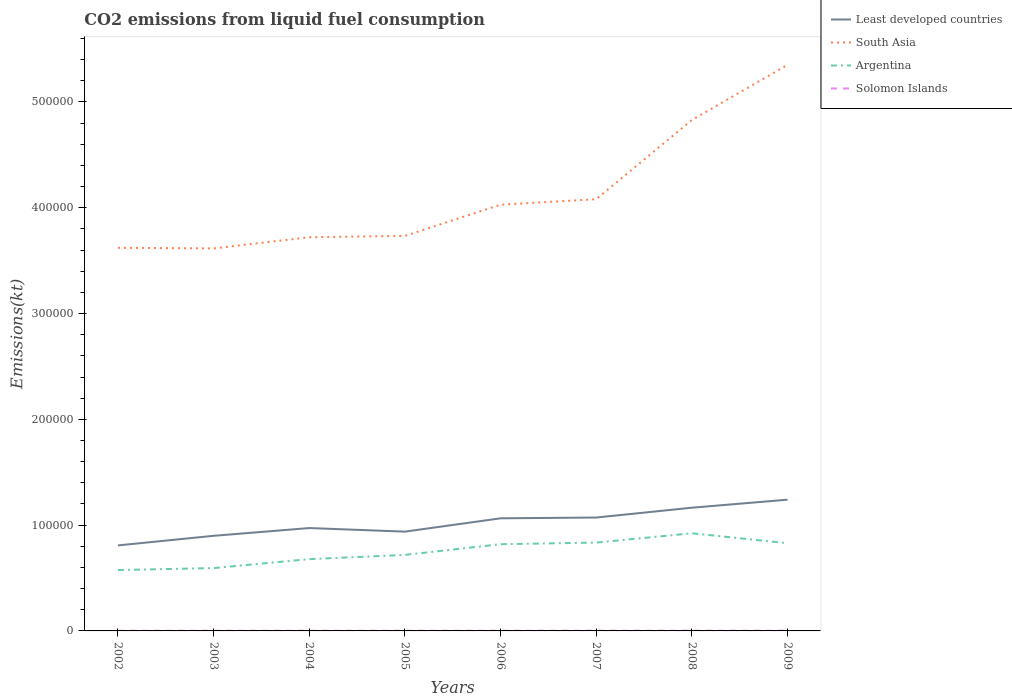How many different coloured lines are there?
Your answer should be very brief. 4. Across all years, what is the maximum amount of CO2 emitted in Argentina?
Your response must be concise. 5.75e+04. What is the total amount of CO2 emitted in Solomon Islands in the graph?
Offer a very short reply. 0. What is the difference between the highest and the second highest amount of CO2 emitted in Least developed countries?
Provide a short and direct response. 4.32e+04. What is the difference between the highest and the lowest amount of CO2 emitted in South Asia?
Your answer should be compact. 2. How many lines are there?
Offer a very short reply. 4. What is the difference between two consecutive major ticks on the Y-axis?
Provide a short and direct response. 1.00e+05. Are the values on the major ticks of Y-axis written in scientific E-notation?
Offer a very short reply. No. Does the graph contain grids?
Provide a succinct answer. No. How many legend labels are there?
Provide a succinct answer. 4. How are the legend labels stacked?
Your response must be concise. Vertical. What is the title of the graph?
Provide a short and direct response. CO2 emissions from liquid fuel consumption. What is the label or title of the X-axis?
Provide a succinct answer. Years. What is the label or title of the Y-axis?
Provide a short and direct response. Emissions(kt). What is the Emissions(kt) in Least developed countries in 2002?
Offer a terse response. 8.08e+04. What is the Emissions(kt) in South Asia in 2002?
Keep it short and to the point. 3.62e+05. What is the Emissions(kt) in Argentina in 2002?
Provide a succinct answer. 5.75e+04. What is the Emissions(kt) of Solomon Islands in 2002?
Offer a terse response. 172.35. What is the Emissions(kt) in Least developed countries in 2003?
Your response must be concise. 8.99e+04. What is the Emissions(kt) of South Asia in 2003?
Your answer should be very brief. 3.62e+05. What is the Emissions(kt) of Argentina in 2003?
Your answer should be very brief. 5.94e+04. What is the Emissions(kt) of Solomon Islands in 2003?
Offer a terse response. 179.68. What is the Emissions(kt) of Least developed countries in 2004?
Offer a terse response. 9.72e+04. What is the Emissions(kt) of South Asia in 2004?
Offer a very short reply. 3.72e+05. What is the Emissions(kt) in Argentina in 2004?
Make the answer very short. 6.79e+04. What is the Emissions(kt) in Solomon Islands in 2004?
Ensure brevity in your answer.  179.68. What is the Emissions(kt) in Least developed countries in 2005?
Make the answer very short. 9.39e+04. What is the Emissions(kt) of South Asia in 2005?
Make the answer very short. 3.73e+05. What is the Emissions(kt) in Argentina in 2005?
Your answer should be compact. 7.19e+04. What is the Emissions(kt) of Solomon Islands in 2005?
Offer a very short reply. 179.68. What is the Emissions(kt) in Least developed countries in 2006?
Your answer should be compact. 1.06e+05. What is the Emissions(kt) in South Asia in 2006?
Make the answer very short. 4.03e+05. What is the Emissions(kt) in Argentina in 2006?
Offer a terse response. 8.20e+04. What is the Emissions(kt) in Solomon Islands in 2006?
Your response must be concise. 179.68. What is the Emissions(kt) of Least developed countries in 2007?
Make the answer very short. 1.07e+05. What is the Emissions(kt) of South Asia in 2007?
Make the answer very short. 4.08e+05. What is the Emissions(kt) in Argentina in 2007?
Provide a succinct answer. 8.35e+04. What is the Emissions(kt) in Solomon Islands in 2007?
Keep it short and to the point. 190.68. What is the Emissions(kt) in Least developed countries in 2008?
Ensure brevity in your answer.  1.16e+05. What is the Emissions(kt) in South Asia in 2008?
Offer a terse response. 4.83e+05. What is the Emissions(kt) in Argentina in 2008?
Offer a terse response. 9.23e+04. What is the Emissions(kt) in Solomon Islands in 2008?
Ensure brevity in your answer.  190.68. What is the Emissions(kt) in Least developed countries in 2009?
Give a very brief answer. 1.24e+05. What is the Emissions(kt) in South Asia in 2009?
Provide a short and direct response. 5.35e+05. What is the Emissions(kt) of Argentina in 2009?
Provide a short and direct response. 8.29e+04. What is the Emissions(kt) in Solomon Islands in 2009?
Offer a terse response. 194.35. Across all years, what is the maximum Emissions(kt) in Least developed countries?
Offer a very short reply. 1.24e+05. Across all years, what is the maximum Emissions(kt) in South Asia?
Give a very brief answer. 5.35e+05. Across all years, what is the maximum Emissions(kt) in Argentina?
Offer a very short reply. 9.23e+04. Across all years, what is the maximum Emissions(kt) in Solomon Islands?
Offer a terse response. 194.35. Across all years, what is the minimum Emissions(kt) of Least developed countries?
Keep it short and to the point. 8.08e+04. Across all years, what is the minimum Emissions(kt) of South Asia?
Your answer should be compact. 3.62e+05. Across all years, what is the minimum Emissions(kt) of Argentina?
Your answer should be very brief. 5.75e+04. Across all years, what is the minimum Emissions(kt) of Solomon Islands?
Your response must be concise. 172.35. What is the total Emissions(kt) of Least developed countries in the graph?
Give a very brief answer. 8.16e+05. What is the total Emissions(kt) of South Asia in the graph?
Keep it short and to the point. 3.30e+06. What is the total Emissions(kt) of Argentina in the graph?
Your answer should be compact. 5.97e+05. What is the total Emissions(kt) of Solomon Islands in the graph?
Make the answer very short. 1466.8. What is the difference between the Emissions(kt) in Least developed countries in 2002 and that in 2003?
Keep it short and to the point. -9081.77. What is the difference between the Emissions(kt) in South Asia in 2002 and that in 2003?
Give a very brief answer. 579.39. What is the difference between the Emissions(kt) in Argentina in 2002 and that in 2003?
Make the answer very short. -1862.84. What is the difference between the Emissions(kt) in Solomon Islands in 2002 and that in 2003?
Offer a terse response. -7.33. What is the difference between the Emissions(kt) in Least developed countries in 2002 and that in 2004?
Ensure brevity in your answer.  -1.64e+04. What is the difference between the Emissions(kt) of South Asia in 2002 and that in 2004?
Offer a very short reply. -9999.91. What is the difference between the Emissions(kt) in Argentina in 2002 and that in 2004?
Ensure brevity in your answer.  -1.03e+04. What is the difference between the Emissions(kt) in Solomon Islands in 2002 and that in 2004?
Your answer should be very brief. -7.33. What is the difference between the Emissions(kt) of Least developed countries in 2002 and that in 2005?
Make the answer very short. -1.30e+04. What is the difference between the Emissions(kt) of South Asia in 2002 and that in 2005?
Provide a short and direct response. -1.13e+04. What is the difference between the Emissions(kt) of Argentina in 2002 and that in 2005?
Offer a terse response. -1.43e+04. What is the difference between the Emissions(kt) of Solomon Islands in 2002 and that in 2005?
Keep it short and to the point. -7.33. What is the difference between the Emissions(kt) of Least developed countries in 2002 and that in 2006?
Keep it short and to the point. -2.56e+04. What is the difference between the Emissions(kt) in South Asia in 2002 and that in 2006?
Provide a succinct answer. -4.08e+04. What is the difference between the Emissions(kt) of Argentina in 2002 and that in 2006?
Offer a very short reply. -2.44e+04. What is the difference between the Emissions(kt) in Solomon Islands in 2002 and that in 2006?
Provide a short and direct response. -7.33. What is the difference between the Emissions(kt) of Least developed countries in 2002 and that in 2007?
Provide a short and direct response. -2.64e+04. What is the difference between the Emissions(kt) in South Asia in 2002 and that in 2007?
Keep it short and to the point. -4.59e+04. What is the difference between the Emissions(kt) in Argentina in 2002 and that in 2007?
Your response must be concise. -2.60e+04. What is the difference between the Emissions(kt) in Solomon Islands in 2002 and that in 2007?
Provide a succinct answer. -18.34. What is the difference between the Emissions(kt) of Least developed countries in 2002 and that in 2008?
Make the answer very short. -3.57e+04. What is the difference between the Emissions(kt) of South Asia in 2002 and that in 2008?
Offer a very short reply. -1.21e+05. What is the difference between the Emissions(kt) in Argentina in 2002 and that in 2008?
Offer a very short reply. -3.48e+04. What is the difference between the Emissions(kt) in Solomon Islands in 2002 and that in 2008?
Give a very brief answer. -18.34. What is the difference between the Emissions(kt) of Least developed countries in 2002 and that in 2009?
Your response must be concise. -4.32e+04. What is the difference between the Emissions(kt) of South Asia in 2002 and that in 2009?
Your answer should be very brief. -1.73e+05. What is the difference between the Emissions(kt) in Argentina in 2002 and that in 2009?
Provide a short and direct response. -2.54e+04. What is the difference between the Emissions(kt) in Solomon Islands in 2002 and that in 2009?
Offer a terse response. -22. What is the difference between the Emissions(kt) of Least developed countries in 2003 and that in 2004?
Your response must be concise. -7332.58. What is the difference between the Emissions(kt) of South Asia in 2003 and that in 2004?
Your response must be concise. -1.06e+04. What is the difference between the Emissions(kt) of Argentina in 2003 and that in 2004?
Offer a very short reply. -8463.44. What is the difference between the Emissions(kt) in Least developed countries in 2003 and that in 2005?
Keep it short and to the point. -3952.29. What is the difference between the Emissions(kt) in South Asia in 2003 and that in 2005?
Offer a terse response. -1.19e+04. What is the difference between the Emissions(kt) of Argentina in 2003 and that in 2005?
Offer a terse response. -1.25e+04. What is the difference between the Emissions(kt) of Solomon Islands in 2003 and that in 2005?
Give a very brief answer. 0. What is the difference between the Emissions(kt) in Least developed countries in 2003 and that in 2006?
Give a very brief answer. -1.65e+04. What is the difference between the Emissions(kt) in South Asia in 2003 and that in 2006?
Your answer should be very brief. -4.14e+04. What is the difference between the Emissions(kt) in Argentina in 2003 and that in 2006?
Your answer should be very brief. -2.26e+04. What is the difference between the Emissions(kt) of Solomon Islands in 2003 and that in 2006?
Provide a succinct answer. 0. What is the difference between the Emissions(kt) of Least developed countries in 2003 and that in 2007?
Offer a terse response. -1.73e+04. What is the difference between the Emissions(kt) in South Asia in 2003 and that in 2007?
Keep it short and to the point. -4.65e+04. What is the difference between the Emissions(kt) in Argentina in 2003 and that in 2007?
Provide a short and direct response. -2.41e+04. What is the difference between the Emissions(kt) in Solomon Islands in 2003 and that in 2007?
Give a very brief answer. -11. What is the difference between the Emissions(kt) of Least developed countries in 2003 and that in 2008?
Keep it short and to the point. -2.66e+04. What is the difference between the Emissions(kt) of South Asia in 2003 and that in 2008?
Offer a very short reply. -1.21e+05. What is the difference between the Emissions(kt) of Argentina in 2003 and that in 2008?
Offer a very short reply. -3.29e+04. What is the difference between the Emissions(kt) in Solomon Islands in 2003 and that in 2008?
Make the answer very short. -11. What is the difference between the Emissions(kt) of Least developed countries in 2003 and that in 2009?
Provide a succinct answer. -3.41e+04. What is the difference between the Emissions(kt) of South Asia in 2003 and that in 2009?
Your response must be concise. -1.74e+05. What is the difference between the Emissions(kt) in Argentina in 2003 and that in 2009?
Offer a terse response. -2.35e+04. What is the difference between the Emissions(kt) in Solomon Islands in 2003 and that in 2009?
Offer a very short reply. -14.67. What is the difference between the Emissions(kt) of Least developed countries in 2004 and that in 2005?
Offer a terse response. 3380.29. What is the difference between the Emissions(kt) of South Asia in 2004 and that in 2005?
Offer a very short reply. -1283.45. What is the difference between the Emissions(kt) of Argentina in 2004 and that in 2005?
Ensure brevity in your answer.  -3989.7. What is the difference between the Emissions(kt) of Solomon Islands in 2004 and that in 2005?
Give a very brief answer. 0. What is the difference between the Emissions(kt) of Least developed countries in 2004 and that in 2006?
Your answer should be very brief. -9199.86. What is the difference between the Emissions(kt) of South Asia in 2004 and that in 2006?
Offer a terse response. -3.08e+04. What is the difference between the Emissions(kt) in Argentina in 2004 and that in 2006?
Offer a very short reply. -1.41e+04. What is the difference between the Emissions(kt) in Least developed countries in 2004 and that in 2007?
Make the answer very short. -9941.61. What is the difference between the Emissions(kt) of South Asia in 2004 and that in 2007?
Your answer should be compact. -3.59e+04. What is the difference between the Emissions(kt) in Argentina in 2004 and that in 2007?
Keep it short and to the point. -1.56e+04. What is the difference between the Emissions(kt) in Solomon Islands in 2004 and that in 2007?
Your answer should be very brief. -11. What is the difference between the Emissions(kt) of Least developed countries in 2004 and that in 2008?
Your answer should be very brief. -1.92e+04. What is the difference between the Emissions(kt) in South Asia in 2004 and that in 2008?
Offer a very short reply. -1.11e+05. What is the difference between the Emissions(kt) of Argentina in 2004 and that in 2008?
Ensure brevity in your answer.  -2.44e+04. What is the difference between the Emissions(kt) of Solomon Islands in 2004 and that in 2008?
Ensure brevity in your answer.  -11. What is the difference between the Emissions(kt) in Least developed countries in 2004 and that in 2009?
Keep it short and to the point. -2.68e+04. What is the difference between the Emissions(kt) in South Asia in 2004 and that in 2009?
Give a very brief answer. -1.63e+05. What is the difference between the Emissions(kt) in Argentina in 2004 and that in 2009?
Give a very brief answer. -1.51e+04. What is the difference between the Emissions(kt) in Solomon Islands in 2004 and that in 2009?
Your answer should be compact. -14.67. What is the difference between the Emissions(kt) in Least developed countries in 2005 and that in 2006?
Keep it short and to the point. -1.26e+04. What is the difference between the Emissions(kt) of South Asia in 2005 and that in 2006?
Ensure brevity in your answer.  -2.95e+04. What is the difference between the Emissions(kt) in Argentina in 2005 and that in 2006?
Your response must be concise. -1.01e+04. What is the difference between the Emissions(kt) in Least developed countries in 2005 and that in 2007?
Make the answer very short. -1.33e+04. What is the difference between the Emissions(kt) of South Asia in 2005 and that in 2007?
Provide a succinct answer. -3.46e+04. What is the difference between the Emissions(kt) of Argentina in 2005 and that in 2007?
Provide a succinct answer. -1.16e+04. What is the difference between the Emissions(kt) of Solomon Islands in 2005 and that in 2007?
Provide a succinct answer. -11. What is the difference between the Emissions(kt) in Least developed countries in 2005 and that in 2008?
Make the answer very short. -2.26e+04. What is the difference between the Emissions(kt) of South Asia in 2005 and that in 2008?
Offer a terse response. -1.10e+05. What is the difference between the Emissions(kt) in Argentina in 2005 and that in 2008?
Provide a short and direct response. -2.05e+04. What is the difference between the Emissions(kt) in Solomon Islands in 2005 and that in 2008?
Keep it short and to the point. -11. What is the difference between the Emissions(kt) in Least developed countries in 2005 and that in 2009?
Your response must be concise. -3.02e+04. What is the difference between the Emissions(kt) of South Asia in 2005 and that in 2009?
Offer a terse response. -1.62e+05. What is the difference between the Emissions(kt) of Argentina in 2005 and that in 2009?
Keep it short and to the point. -1.11e+04. What is the difference between the Emissions(kt) in Solomon Islands in 2005 and that in 2009?
Offer a very short reply. -14.67. What is the difference between the Emissions(kt) of Least developed countries in 2006 and that in 2007?
Make the answer very short. -741.75. What is the difference between the Emissions(kt) in South Asia in 2006 and that in 2007?
Ensure brevity in your answer.  -5148.47. What is the difference between the Emissions(kt) in Argentina in 2006 and that in 2007?
Offer a terse response. -1518.14. What is the difference between the Emissions(kt) of Solomon Islands in 2006 and that in 2007?
Provide a succinct answer. -11. What is the difference between the Emissions(kt) of Least developed countries in 2006 and that in 2008?
Provide a short and direct response. -1.00e+04. What is the difference between the Emissions(kt) in South Asia in 2006 and that in 2008?
Provide a succinct answer. -8.00e+04. What is the difference between the Emissions(kt) of Argentina in 2006 and that in 2008?
Offer a very short reply. -1.03e+04. What is the difference between the Emissions(kt) of Solomon Islands in 2006 and that in 2008?
Your answer should be very brief. -11. What is the difference between the Emissions(kt) of Least developed countries in 2006 and that in 2009?
Your answer should be compact. -1.76e+04. What is the difference between the Emissions(kt) in South Asia in 2006 and that in 2009?
Provide a short and direct response. -1.32e+05. What is the difference between the Emissions(kt) in Argentina in 2006 and that in 2009?
Your answer should be compact. -942.42. What is the difference between the Emissions(kt) in Solomon Islands in 2006 and that in 2009?
Offer a terse response. -14.67. What is the difference between the Emissions(kt) in Least developed countries in 2007 and that in 2008?
Make the answer very short. -9295.17. What is the difference between the Emissions(kt) in South Asia in 2007 and that in 2008?
Your response must be concise. -7.49e+04. What is the difference between the Emissions(kt) in Argentina in 2007 and that in 2008?
Your response must be concise. -8815.47. What is the difference between the Emissions(kt) in Solomon Islands in 2007 and that in 2008?
Offer a terse response. 0. What is the difference between the Emissions(kt) of Least developed countries in 2007 and that in 2009?
Provide a short and direct response. -1.69e+04. What is the difference between the Emissions(kt) in South Asia in 2007 and that in 2009?
Offer a very short reply. -1.27e+05. What is the difference between the Emissions(kt) in Argentina in 2007 and that in 2009?
Your response must be concise. 575.72. What is the difference between the Emissions(kt) of Solomon Islands in 2007 and that in 2009?
Your answer should be very brief. -3.67. What is the difference between the Emissions(kt) in Least developed countries in 2008 and that in 2009?
Make the answer very short. -7571.93. What is the difference between the Emissions(kt) in South Asia in 2008 and that in 2009?
Give a very brief answer. -5.21e+04. What is the difference between the Emissions(kt) of Argentina in 2008 and that in 2009?
Make the answer very short. 9391.19. What is the difference between the Emissions(kt) of Solomon Islands in 2008 and that in 2009?
Ensure brevity in your answer.  -3.67. What is the difference between the Emissions(kt) of Least developed countries in 2002 and the Emissions(kt) of South Asia in 2003?
Keep it short and to the point. -2.81e+05. What is the difference between the Emissions(kt) of Least developed countries in 2002 and the Emissions(kt) of Argentina in 2003?
Your answer should be very brief. 2.14e+04. What is the difference between the Emissions(kt) of Least developed countries in 2002 and the Emissions(kt) of Solomon Islands in 2003?
Offer a terse response. 8.06e+04. What is the difference between the Emissions(kt) in South Asia in 2002 and the Emissions(kt) in Argentina in 2003?
Offer a very short reply. 3.03e+05. What is the difference between the Emissions(kt) in South Asia in 2002 and the Emissions(kt) in Solomon Islands in 2003?
Offer a terse response. 3.62e+05. What is the difference between the Emissions(kt) in Argentina in 2002 and the Emissions(kt) in Solomon Islands in 2003?
Make the answer very short. 5.74e+04. What is the difference between the Emissions(kt) in Least developed countries in 2002 and the Emissions(kt) in South Asia in 2004?
Provide a short and direct response. -2.91e+05. What is the difference between the Emissions(kt) in Least developed countries in 2002 and the Emissions(kt) in Argentina in 2004?
Your answer should be very brief. 1.30e+04. What is the difference between the Emissions(kt) in Least developed countries in 2002 and the Emissions(kt) in Solomon Islands in 2004?
Offer a very short reply. 8.06e+04. What is the difference between the Emissions(kt) in South Asia in 2002 and the Emissions(kt) in Argentina in 2004?
Provide a succinct answer. 2.94e+05. What is the difference between the Emissions(kt) in South Asia in 2002 and the Emissions(kt) in Solomon Islands in 2004?
Give a very brief answer. 3.62e+05. What is the difference between the Emissions(kt) of Argentina in 2002 and the Emissions(kt) of Solomon Islands in 2004?
Keep it short and to the point. 5.74e+04. What is the difference between the Emissions(kt) of Least developed countries in 2002 and the Emissions(kt) of South Asia in 2005?
Give a very brief answer. -2.93e+05. What is the difference between the Emissions(kt) in Least developed countries in 2002 and the Emissions(kt) in Argentina in 2005?
Provide a short and direct response. 8969.63. What is the difference between the Emissions(kt) in Least developed countries in 2002 and the Emissions(kt) in Solomon Islands in 2005?
Keep it short and to the point. 8.06e+04. What is the difference between the Emissions(kt) in South Asia in 2002 and the Emissions(kt) in Argentina in 2005?
Offer a very short reply. 2.90e+05. What is the difference between the Emissions(kt) of South Asia in 2002 and the Emissions(kt) of Solomon Islands in 2005?
Ensure brevity in your answer.  3.62e+05. What is the difference between the Emissions(kt) of Argentina in 2002 and the Emissions(kt) of Solomon Islands in 2005?
Make the answer very short. 5.74e+04. What is the difference between the Emissions(kt) of Least developed countries in 2002 and the Emissions(kt) of South Asia in 2006?
Offer a very short reply. -3.22e+05. What is the difference between the Emissions(kt) in Least developed countries in 2002 and the Emissions(kt) in Argentina in 2006?
Keep it short and to the point. -1151.29. What is the difference between the Emissions(kt) of Least developed countries in 2002 and the Emissions(kt) of Solomon Islands in 2006?
Your answer should be very brief. 8.06e+04. What is the difference between the Emissions(kt) in South Asia in 2002 and the Emissions(kt) in Argentina in 2006?
Your answer should be compact. 2.80e+05. What is the difference between the Emissions(kt) in South Asia in 2002 and the Emissions(kt) in Solomon Islands in 2006?
Provide a succinct answer. 3.62e+05. What is the difference between the Emissions(kt) in Argentina in 2002 and the Emissions(kt) in Solomon Islands in 2006?
Your answer should be compact. 5.74e+04. What is the difference between the Emissions(kt) in Least developed countries in 2002 and the Emissions(kt) in South Asia in 2007?
Keep it short and to the point. -3.27e+05. What is the difference between the Emissions(kt) in Least developed countries in 2002 and the Emissions(kt) in Argentina in 2007?
Your answer should be very brief. -2669.43. What is the difference between the Emissions(kt) in Least developed countries in 2002 and the Emissions(kt) in Solomon Islands in 2007?
Offer a very short reply. 8.06e+04. What is the difference between the Emissions(kt) of South Asia in 2002 and the Emissions(kt) of Argentina in 2007?
Provide a short and direct response. 2.79e+05. What is the difference between the Emissions(kt) of South Asia in 2002 and the Emissions(kt) of Solomon Islands in 2007?
Offer a terse response. 3.62e+05. What is the difference between the Emissions(kt) in Argentina in 2002 and the Emissions(kt) in Solomon Islands in 2007?
Give a very brief answer. 5.74e+04. What is the difference between the Emissions(kt) in Least developed countries in 2002 and the Emissions(kt) in South Asia in 2008?
Provide a succinct answer. -4.02e+05. What is the difference between the Emissions(kt) of Least developed countries in 2002 and the Emissions(kt) of Argentina in 2008?
Provide a short and direct response. -1.15e+04. What is the difference between the Emissions(kt) of Least developed countries in 2002 and the Emissions(kt) of Solomon Islands in 2008?
Keep it short and to the point. 8.06e+04. What is the difference between the Emissions(kt) in South Asia in 2002 and the Emissions(kt) in Argentina in 2008?
Your answer should be compact. 2.70e+05. What is the difference between the Emissions(kt) in South Asia in 2002 and the Emissions(kt) in Solomon Islands in 2008?
Ensure brevity in your answer.  3.62e+05. What is the difference between the Emissions(kt) of Argentina in 2002 and the Emissions(kt) of Solomon Islands in 2008?
Make the answer very short. 5.74e+04. What is the difference between the Emissions(kt) in Least developed countries in 2002 and the Emissions(kt) in South Asia in 2009?
Give a very brief answer. -4.54e+05. What is the difference between the Emissions(kt) of Least developed countries in 2002 and the Emissions(kt) of Argentina in 2009?
Offer a very short reply. -2093.71. What is the difference between the Emissions(kt) of Least developed countries in 2002 and the Emissions(kt) of Solomon Islands in 2009?
Your answer should be compact. 8.06e+04. What is the difference between the Emissions(kt) of South Asia in 2002 and the Emissions(kt) of Argentina in 2009?
Keep it short and to the point. 2.79e+05. What is the difference between the Emissions(kt) in South Asia in 2002 and the Emissions(kt) in Solomon Islands in 2009?
Give a very brief answer. 3.62e+05. What is the difference between the Emissions(kt) in Argentina in 2002 and the Emissions(kt) in Solomon Islands in 2009?
Offer a terse response. 5.73e+04. What is the difference between the Emissions(kt) in Least developed countries in 2003 and the Emissions(kt) in South Asia in 2004?
Ensure brevity in your answer.  -2.82e+05. What is the difference between the Emissions(kt) of Least developed countries in 2003 and the Emissions(kt) of Argentina in 2004?
Your answer should be compact. 2.20e+04. What is the difference between the Emissions(kt) of Least developed countries in 2003 and the Emissions(kt) of Solomon Islands in 2004?
Your answer should be compact. 8.97e+04. What is the difference between the Emissions(kt) of South Asia in 2003 and the Emissions(kt) of Argentina in 2004?
Your response must be concise. 2.94e+05. What is the difference between the Emissions(kt) of South Asia in 2003 and the Emissions(kt) of Solomon Islands in 2004?
Offer a very short reply. 3.61e+05. What is the difference between the Emissions(kt) in Argentina in 2003 and the Emissions(kt) in Solomon Islands in 2004?
Ensure brevity in your answer.  5.92e+04. What is the difference between the Emissions(kt) in Least developed countries in 2003 and the Emissions(kt) in South Asia in 2005?
Give a very brief answer. -2.84e+05. What is the difference between the Emissions(kt) of Least developed countries in 2003 and the Emissions(kt) of Argentina in 2005?
Offer a very short reply. 1.81e+04. What is the difference between the Emissions(kt) of Least developed countries in 2003 and the Emissions(kt) of Solomon Islands in 2005?
Offer a terse response. 8.97e+04. What is the difference between the Emissions(kt) of South Asia in 2003 and the Emissions(kt) of Argentina in 2005?
Your answer should be very brief. 2.90e+05. What is the difference between the Emissions(kt) in South Asia in 2003 and the Emissions(kt) in Solomon Islands in 2005?
Make the answer very short. 3.61e+05. What is the difference between the Emissions(kt) in Argentina in 2003 and the Emissions(kt) in Solomon Islands in 2005?
Provide a short and direct response. 5.92e+04. What is the difference between the Emissions(kt) of Least developed countries in 2003 and the Emissions(kt) of South Asia in 2006?
Your response must be concise. -3.13e+05. What is the difference between the Emissions(kt) in Least developed countries in 2003 and the Emissions(kt) in Argentina in 2006?
Make the answer very short. 7930.49. What is the difference between the Emissions(kt) of Least developed countries in 2003 and the Emissions(kt) of Solomon Islands in 2006?
Your answer should be compact. 8.97e+04. What is the difference between the Emissions(kt) in South Asia in 2003 and the Emissions(kt) in Argentina in 2006?
Ensure brevity in your answer.  2.80e+05. What is the difference between the Emissions(kt) in South Asia in 2003 and the Emissions(kt) in Solomon Islands in 2006?
Your response must be concise. 3.61e+05. What is the difference between the Emissions(kt) of Argentina in 2003 and the Emissions(kt) of Solomon Islands in 2006?
Make the answer very short. 5.92e+04. What is the difference between the Emissions(kt) of Least developed countries in 2003 and the Emissions(kt) of South Asia in 2007?
Ensure brevity in your answer.  -3.18e+05. What is the difference between the Emissions(kt) in Least developed countries in 2003 and the Emissions(kt) in Argentina in 2007?
Provide a short and direct response. 6412.35. What is the difference between the Emissions(kt) of Least developed countries in 2003 and the Emissions(kt) of Solomon Islands in 2007?
Provide a succinct answer. 8.97e+04. What is the difference between the Emissions(kt) of South Asia in 2003 and the Emissions(kt) of Argentina in 2007?
Ensure brevity in your answer.  2.78e+05. What is the difference between the Emissions(kt) of South Asia in 2003 and the Emissions(kt) of Solomon Islands in 2007?
Your answer should be very brief. 3.61e+05. What is the difference between the Emissions(kt) in Argentina in 2003 and the Emissions(kt) in Solomon Islands in 2007?
Provide a short and direct response. 5.92e+04. What is the difference between the Emissions(kt) of Least developed countries in 2003 and the Emissions(kt) of South Asia in 2008?
Provide a short and direct response. -3.93e+05. What is the difference between the Emissions(kt) in Least developed countries in 2003 and the Emissions(kt) in Argentina in 2008?
Ensure brevity in your answer.  -2403.12. What is the difference between the Emissions(kt) of Least developed countries in 2003 and the Emissions(kt) of Solomon Islands in 2008?
Keep it short and to the point. 8.97e+04. What is the difference between the Emissions(kt) of South Asia in 2003 and the Emissions(kt) of Argentina in 2008?
Make the answer very short. 2.69e+05. What is the difference between the Emissions(kt) in South Asia in 2003 and the Emissions(kt) in Solomon Islands in 2008?
Offer a very short reply. 3.61e+05. What is the difference between the Emissions(kt) of Argentina in 2003 and the Emissions(kt) of Solomon Islands in 2008?
Provide a short and direct response. 5.92e+04. What is the difference between the Emissions(kt) in Least developed countries in 2003 and the Emissions(kt) in South Asia in 2009?
Keep it short and to the point. -4.45e+05. What is the difference between the Emissions(kt) in Least developed countries in 2003 and the Emissions(kt) in Argentina in 2009?
Provide a short and direct response. 6988.07. What is the difference between the Emissions(kt) of Least developed countries in 2003 and the Emissions(kt) of Solomon Islands in 2009?
Offer a very short reply. 8.97e+04. What is the difference between the Emissions(kt) in South Asia in 2003 and the Emissions(kt) in Argentina in 2009?
Your answer should be compact. 2.79e+05. What is the difference between the Emissions(kt) of South Asia in 2003 and the Emissions(kt) of Solomon Islands in 2009?
Your response must be concise. 3.61e+05. What is the difference between the Emissions(kt) of Argentina in 2003 and the Emissions(kt) of Solomon Islands in 2009?
Your answer should be compact. 5.92e+04. What is the difference between the Emissions(kt) of Least developed countries in 2004 and the Emissions(kt) of South Asia in 2005?
Provide a succinct answer. -2.76e+05. What is the difference between the Emissions(kt) of Least developed countries in 2004 and the Emissions(kt) of Argentina in 2005?
Provide a succinct answer. 2.54e+04. What is the difference between the Emissions(kt) in Least developed countries in 2004 and the Emissions(kt) in Solomon Islands in 2005?
Offer a terse response. 9.71e+04. What is the difference between the Emissions(kt) of South Asia in 2004 and the Emissions(kt) of Argentina in 2005?
Provide a short and direct response. 3.00e+05. What is the difference between the Emissions(kt) in South Asia in 2004 and the Emissions(kt) in Solomon Islands in 2005?
Offer a terse response. 3.72e+05. What is the difference between the Emissions(kt) in Argentina in 2004 and the Emissions(kt) in Solomon Islands in 2005?
Ensure brevity in your answer.  6.77e+04. What is the difference between the Emissions(kt) of Least developed countries in 2004 and the Emissions(kt) of South Asia in 2006?
Your answer should be compact. -3.06e+05. What is the difference between the Emissions(kt) of Least developed countries in 2004 and the Emissions(kt) of Argentina in 2006?
Your response must be concise. 1.53e+04. What is the difference between the Emissions(kt) of Least developed countries in 2004 and the Emissions(kt) of Solomon Islands in 2006?
Your answer should be very brief. 9.71e+04. What is the difference between the Emissions(kt) of South Asia in 2004 and the Emissions(kt) of Argentina in 2006?
Ensure brevity in your answer.  2.90e+05. What is the difference between the Emissions(kt) of South Asia in 2004 and the Emissions(kt) of Solomon Islands in 2006?
Make the answer very short. 3.72e+05. What is the difference between the Emissions(kt) of Argentina in 2004 and the Emissions(kt) of Solomon Islands in 2006?
Keep it short and to the point. 6.77e+04. What is the difference between the Emissions(kt) in Least developed countries in 2004 and the Emissions(kt) in South Asia in 2007?
Offer a very short reply. -3.11e+05. What is the difference between the Emissions(kt) in Least developed countries in 2004 and the Emissions(kt) in Argentina in 2007?
Your answer should be compact. 1.37e+04. What is the difference between the Emissions(kt) in Least developed countries in 2004 and the Emissions(kt) in Solomon Islands in 2007?
Offer a very short reply. 9.71e+04. What is the difference between the Emissions(kt) of South Asia in 2004 and the Emissions(kt) of Argentina in 2007?
Offer a terse response. 2.89e+05. What is the difference between the Emissions(kt) of South Asia in 2004 and the Emissions(kt) of Solomon Islands in 2007?
Your response must be concise. 3.72e+05. What is the difference between the Emissions(kt) in Argentina in 2004 and the Emissions(kt) in Solomon Islands in 2007?
Ensure brevity in your answer.  6.77e+04. What is the difference between the Emissions(kt) of Least developed countries in 2004 and the Emissions(kt) of South Asia in 2008?
Your response must be concise. -3.86e+05. What is the difference between the Emissions(kt) in Least developed countries in 2004 and the Emissions(kt) in Argentina in 2008?
Offer a very short reply. 4929.46. What is the difference between the Emissions(kt) of Least developed countries in 2004 and the Emissions(kt) of Solomon Islands in 2008?
Provide a short and direct response. 9.71e+04. What is the difference between the Emissions(kt) of South Asia in 2004 and the Emissions(kt) of Argentina in 2008?
Offer a very short reply. 2.80e+05. What is the difference between the Emissions(kt) in South Asia in 2004 and the Emissions(kt) in Solomon Islands in 2008?
Your answer should be very brief. 3.72e+05. What is the difference between the Emissions(kt) in Argentina in 2004 and the Emissions(kt) in Solomon Islands in 2008?
Offer a terse response. 6.77e+04. What is the difference between the Emissions(kt) in Least developed countries in 2004 and the Emissions(kt) in South Asia in 2009?
Make the answer very short. -4.38e+05. What is the difference between the Emissions(kt) in Least developed countries in 2004 and the Emissions(kt) in Argentina in 2009?
Keep it short and to the point. 1.43e+04. What is the difference between the Emissions(kt) in Least developed countries in 2004 and the Emissions(kt) in Solomon Islands in 2009?
Keep it short and to the point. 9.70e+04. What is the difference between the Emissions(kt) in South Asia in 2004 and the Emissions(kt) in Argentina in 2009?
Offer a very short reply. 2.89e+05. What is the difference between the Emissions(kt) in South Asia in 2004 and the Emissions(kt) in Solomon Islands in 2009?
Your answer should be compact. 3.72e+05. What is the difference between the Emissions(kt) in Argentina in 2004 and the Emissions(kt) in Solomon Islands in 2009?
Your answer should be very brief. 6.77e+04. What is the difference between the Emissions(kt) in Least developed countries in 2005 and the Emissions(kt) in South Asia in 2006?
Provide a succinct answer. -3.09e+05. What is the difference between the Emissions(kt) of Least developed countries in 2005 and the Emissions(kt) of Argentina in 2006?
Provide a succinct answer. 1.19e+04. What is the difference between the Emissions(kt) of Least developed countries in 2005 and the Emissions(kt) of Solomon Islands in 2006?
Provide a short and direct response. 9.37e+04. What is the difference between the Emissions(kt) of South Asia in 2005 and the Emissions(kt) of Argentina in 2006?
Provide a succinct answer. 2.91e+05. What is the difference between the Emissions(kt) of South Asia in 2005 and the Emissions(kt) of Solomon Islands in 2006?
Provide a succinct answer. 3.73e+05. What is the difference between the Emissions(kt) of Argentina in 2005 and the Emissions(kt) of Solomon Islands in 2006?
Your response must be concise. 7.17e+04. What is the difference between the Emissions(kt) of Least developed countries in 2005 and the Emissions(kt) of South Asia in 2007?
Provide a succinct answer. -3.14e+05. What is the difference between the Emissions(kt) in Least developed countries in 2005 and the Emissions(kt) in Argentina in 2007?
Keep it short and to the point. 1.04e+04. What is the difference between the Emissions(kt) of Least developed countries in 2005 and the Emissions(kt) of Solomon Islands in 2007?
Offer a very short reply. 9.37e+04. What is the difference between the Emissions(kt) in South Asia in 2005 and the Emissions(kt) in Argentina in 2007?
Your response must be concise. 2.90e+05. What is the difference between the Emissions(kt) of South Asia in 2005 and the Emissions(kt) of Solomon Islands in 2007?
Your response must be concise. 3.73e+05. What is the difference between the Emissions(kt) of Argentina in 2005 and the Emissions(kt) of Solomon Islands in 2007?
Offer a very short reply. 7.17e+04. What is the difference between the Emissions(kt) in Least developed countries in 2005 and the Emissions(kt) in South Asia in 2008?
Offer a very short reply. -3.89e+05. What is the difference between the Emissions(kt) in Least developed countries in 2005 and the Emissions(kt) in Argentina in 2008?
Your answer should be compact. 1549.17. What is the difference between the Emissions(kt) of Least developed countries in 2005 and the Emissions(kt) of Solomon Islands in 2008?
Provide a succinct answer. 9.37e+04. What is the difference between the Emissions(kt) in South Asia in 2005 and the Emissions(kt) in Argentina in 2008?
Ensure brevity in your answer.  2.81e+05. What is the difference between the Emissions(kt) of South Asia in 2005 and the Emissions(kt) of Solomon Islands in 2008?
Keep it short and to the point. 3.73e+05. What is the difference between the Emissions(kt) in Argentina in 2005 and the Emissions(kt) in Solomon Islands in 2008?
Your response must be concise. 7.17e+04. What is the difference between the Emissions(kt) in Least developed countries in 2005 and the Emissions(kt) in South Asia in 2009?
Your answer should be compact. -4.41e+05. What is the difference between the Emissions(kt) in Least developed countries in 2005 and the Emissions(kt) in Argentina in 2009?
Offer a terse response. 1.09e+04. What is the difference between the Emissions(kt) of Least developed countries in 2005 and the Emissions(kt) of Solomon Islands in 2009?
Keep it short and to the point. 9.37e+04. What is the difference between the Emissions(kt) of South Asia in 2005 and the Emissions(kt) of Argentina in 2009?
Ensure brevity in your answer.  2.91e+05. What is the difference between the Emissions(kt) in South Asia in 2005 and the Emissions(kt) in Solomon Islands in 2009?
Offer a terse response. 3.73e+05. What is the difference between the Emissions(kt) in Argentina in 2005 and the Emissions(kt) in Solomon Islands in 2009?
Offer a very short reply. 7.17e+04. What is the difference between the Emissions(kt) in Least developed countries in 2006 and the Emissions(kt) in South Asia in 2007?
Keep it short and to the point. -3.02e+05. What is the difference between the Emissions(kt) in Least developed countries in 2006 and the Emissions(kt) in Argentina in 2007?
Keep it short and to the point. 2.29e+04. What is the difference between the Emissions(kt) of Least developed countries in 2006 and the Emissions(kt) of Solomon Islands in 2007?
Keep it short and to the point. 1.06e+05. What is the difference between the Emissions(kt) of South Asia in 2006 and the Emissions(kt) of Argentina in 2007?
Make the answer very short. 3.19e+05. What is the difference between the Emissions(kt) of South Asia in 2006 and the Emissions(kt) of Solomon Islands in 2007?
Ensure brevity in your answer.  4.03e+05. What is the difference between the Emissions(kt) in Argentina in 2006 and the Emissions(kt) in Solomon Islands in 2007?
Your response must be concise. 8.18e+04. What is the difference between the Emissions(kt) in Least developed countries in 2006 and the Emissions(kt) in South Asia in 2008?
Your answer should be compact. -3.77e+05. What is the difference between the Emissions(kt) in Least developed countries in 2006 and the Emissions(kt) in Argentina in 2008?
Provide a short and direct response. 1.41e+04. What is the difference between the Emissions(kt) of Least developed countries in 2006 and the Emissions(kt) of Solomon Islands in 2008?
Ensure brevity in your answer.  1.06e+05. What is the difference between the Emissions(kt) of South Asia in 2006 and the Emissions(kt) of Argentina in 2008?
Your answer should be very brief. 3.11e+05. What is the difference between the Emissions(kt) of South Asia in 2006 and the Emissions(kt) of Solomon Islands in 2008?
Your answer should be very brief. 4.03e+05. What is the difference between the Emissions(kt) of Argentina in 2006 and the Emissions(kt) of Solomon Islands in 2008?
Your answer should be compact. 8.18e+04. What is the difference between the Emissions(kt) of Least developed countries in 2006 and the Emissions(kt) of South Asia in 2009?
Provide a short and direct response. -4.29e+05. What is the difference between the Emissions(kt) of Least developed countries in 2006 and the Emissions(kt) of Argentina in 2009?
Ensure brevity in your answer.  2.35e+04. What is the difference between the Emissions(kt) in Least developed countries in 2006 and the Emissions(kt) in Solomon Islands in 2009?
Offer a very short reply. 1.06e+05. What is the difference between the Emissions(kt) in South Asia in 2006 and the Emissions(kt) in Argentina in 2009?
Give a very brief answer. 3.20e+05. What is the difference between the Emissions(kt) in South Asia in 2006 and the Emissions(kt) in Solomon Islands in 2009?
Give a very brief answer. 4.03e+05. What is the difference between the Emissions(kt) of Argentina in 2006 and the Emissions(kt) of Solomon Islands in 2009?
Offer a very short reply. 8.18e+04. What is the difference between the Emissions(kt) of Least developed countries in 2007 and the Emissions(kt) of South Asia in 2008?
Your answer should be very brief. -3.76e+05. What is the difference between the Emissions(kt) in Least developed countries in 2007 and the Emissions(kt) in Argentina in 2008?
Provide a short and direct response. 1.49e+04. What is the difference between the Emissions(kt) of Least developed countries in 2007 and the Emissions(kt) of Solomon Islands in 2008?
Ensure brevity in your answer.  1.07e+05. What is the difference between the Emissions(kt) in South Asia in 2007 and the Emissions(kt) in Argentina in 2008?
Make the answer very short. 3.16e+05. What is the difference between the Emissions(kt) in South Asia in 2007 and the Emissions(kt) in Solomon Islands in 2008?
Make the answer very short. 4.08e+05. What is the difference between the Emissions(kt) of Argentina in 2007 and the Emissions(kt) of Solomon Islands in 2008?
Keep it short and to the point. 8.33e+04. What is the difference between the Emissions(kt) in Least developed countries in 2007 and the Emissions(kt) in South Asia in 2009?
Offer a very short reply. -4.28e+05. What is the difference between the Emissions(kt) in Least developed countries in 2007 and the Emissions(kt) in Argentina in 2009?
Your response must be concise. 2.43e+04. What is the difference between the Emissions(kt) of Least developed countries in 2007 and the Emissions(kt) of Solomon Islands in 2009?
Your response must be concise. 1.07e+05. What is the difference between the Emissions(kt) in South Asia in 2007 and the Emissions(kt) in Argentina in 2009?
Make the answer very short. 3.25e+05. What is the difference between the Emissions(kt) of South Asia in 2007 and the Emissions(kt) of Solomon Islands in 2009?
Make the answer very short. 4.08e+05. What is the difference between the Emissions(kt) of Argentina in 2007 and the Emissions(kt) of Solomon Islands in 2009?
Your answer should be compact. 8.33e+04. What is the difference between the Emissions(kt) of Least developed countries in 2008 and the Emissions(kt) of South Asia in 2009?
Keep it short and to the point. -4.19e+05. What is the difference between the Emissions(kt) of Least developed countries in 2008 and the Emissions(kt) of Argentina in 2009?
Your answer should be very brief. 3.36e+04. What is the difference between the Emissions(kt) of Least developed countries in 2008 and the Emissions(kt) of Solomon Islands in 2009?
Give a very brief answer. 1.16e+05. What is the difference between the Emissions(kt) of South Asia in 2008 and the Emissions(kt) of Argentina in 2009?
Ensure brevity in your answer.  4.00e+05. What is the difference between the Emissions(kt) in South Asia in 2008 and the Emissions(kt) in Solomon Islands in 2009?
Ensure brevity in your answer.  4.83e+05. What is the difference between the Emissions(kt) of Argentina in 2008 and the Emissions(kt) of Solomon Islands in 2009?
Keep it short and to the point. 9.21e+04. What is the average Emissions(kt) of Least developed countries per year?
Make the answer very short. 1.02e+05. What is the average Emissions(kt) of South Asia per year?
Make the answer very short. 4.12e+05. What is the average Emissions(kt) in Argentina per year?
Your answer should be compact. 7.47e+04. What is the average Emissions(kt) of Solomon Islands per year?
Give a very brief answer. 183.35. In the year 2002, what is the difference between the Emissions(kt) in Least developed countries and Emissions(kt) in South Asia?
Make the answer very short. -2.81e+05. In the year 2002, what is the difference between the Emissions(kt) of Least developed countries and Emissions(kt) of Argentina?
Your answer should be compact. 2.33e+04. In the year 2002, what is the difference between the Emissions(kt) in Least developed countries and Emissions(kt) in Solomon Islands?
Offer a very short reply. 8.07e+04. In the year 2002, what is the difference between the Emissions(kt) of South Asia and Emissions(kt) of Argentina?
Your answer should be very brief. 3.05e+05. In the year 2002, what is the difference between the Emissions(kt) of South Asia and Emissions(kt) of Solomon Islands?
Your response must be concise. 3.62e+05. In the year 2002, what is the difference between the Emissions(kt) in Argentina and Emissions(kt) in Solomon Islands?
Offer a terse response. 5.74e+04. In the year 2003, what is the difference between the Emissions(kt) of Least developed countries and Emissions(kt) of South Asia?
Keep it short and to the point. -2.72e+05. In the year 2003, what is the difference between the Emissions(kt) in Least developed countries and Emissions(kt) in Argentina?
Your response must be concise. 3.05e+04. In the year 2003, what is the difference between the Emissions(kt) of Least developed countries and Emissions(kt) of Solomon Islands?
Your answer should be very brief. 8.97e+04. In the year 2003, what is the difference between the Emissions(kt) in South Asia and Emissions(kt) in Argentina?
Offer a terse response. 3.02e+05. In the year 2003, what is the difference between the Emissions(kt) of South Asia and Emissions(kt) of Solomon Islands?
Provide a short and direct response. 3.61e+05. In the year 2003, what is the difference between the Emissions(kt) of Argentina and Emissions(kt) of Solomon Islands?
Your response must be concise. 5.92e+04. In the year 2004, what is the difference between the Emissions(kt) in Least developed countries and Emissions(kt) in South Asia?
Your answer should be very brief. -2.75e+05. In the year 2004, what is the difference between the Emissions(kt) in Least developed countries and Emissions(kt) in Argentina?
Your response must be concise. 2.94e+04. In the year 2004, what is the difference between the Emissions(kt) of Least developed countries and Emissions(kt) of Solomon Islands?
Offer a terse response. 9.71e+04. In the year 2004, what is the difference between the Emissions(kt) of South Asia and Emissions(kt) of Argentina?
Keep it short and to the point. 3.04e+05. In the year 2004, what is the difference between the Emissions(kt) of South Asia and Emissions(kt) of Solomon Islands?
Your answer should be compact. 3.72e+05. In the year 2004, what is the difference between the Emissions(kt) of Argentina and Emissions(kt) of Solomon Islands?
Make the answer very short. 6.77e+04. In the year 2005, what is the difference between the Emissions(kt) of Least developed countries and Emissions(kt) of South Asia?
Provide a succinct answer. -2.80e+05. In the year 2005, what is the difference between the Emissions(kt) of Least developed countries and Emissions(kt) of Argentina?
Ensure brevity in your answer.  2.20e+04. In the year 2005, what is the difference between the Emissions(kt) of Least developed countries and Emissions(kt) of Solomon Islands?
Give a very brief answer. 9.37e+04. In the year 2005, what is the difference between the Emissions(kt) of South Asia and Emissions(kt) of Argentina?
Give a very brief answer. 3.02e+05. In the year 2005, what is the difference between the Emissions(kt) of South Asia and Emissions(kt) of Solomon Islands?
Provide a succinct answer. 3.73e+05. In the year 2005, what is the difference between the Emissions(kt) in Argentina and Emissions(kt) in Solomon Islands?
Ensure brevity in your answer.  7.17e+04. In the year 2006, what is the difference between the Emissions(kt) of Least developed countries and Emissions(kt) of South Asia?
Your response must be concise. -2.96e+05. In the year 2006, what is the difference between the Emissions(kt) in Least developed countries and Emissions(kt) in Argentina?
Make the answer very short. 2.45e+04. In the year 2006, what is the difference between the Emissions(kt) of Least developed countries and Emissions(kt) of Solomon Islands?
Give a very brief answer. 1.06e+05. In the year 2006, what is the difference between the Emissions(kt) of South Asia and Emissions(kt) of Argentina?
Offer a very short reply. 3.21e+05. In the year 2006, what is the difference between the Emissions(kt) in South Asia and Emissions(kt) in Solomon Islands?
Your answer should be compact. 4.03e+05. In the year 2006, what is the difference between the Emissions(kt) in Argentina and Emissions(kt) in Solomon Islands?
Ensure brevity in your answer.  8.18e+04. In the year 2007, what is the difference between the Emissions(kt) of Least developed countries and Emissions(kt) of South Asia?
Your answer should be compact. -3.01e+05. In the year 2007, what is the difference between the Emissions(kt) in Least developed countries and Emissions(kt) in Argentina?
Keep it short and to the point. 2.37e+04. In the year 2007, what is the difference between the Emissions(kt) of Least developed countries and Emissions(kt) of Solomon Islands?
Ensure brevity in your answer.  1.07e+05. In the year 2007, what is the difference between the Emissions(kt) of South Asia and Emissions(kt) of Argentina?
Provide a short and direct response. 3.25e+05. In the year 2007, what is the difference between the Emissions(kt) in South Asia and Emissions(kt) in Solomon Islands?
Your answer should be compact. 4.08e+05. In the year 2007, what is the difference between the Emissions(kt) in Argentina and Emissions(kt) in Solomon Islands?
Provide a short and direct response. 8.33e+04. In the year 2008, what is the difference between the Emissions(kt) of Least developed countries and Emissions(kt) of South Asia?
Your response must be concise. -3.66e+05. In the year 2008, what is the difference between the Emissions(kt) in Least developed countries and Emissions(kt) in Argentina?
Your response must be concise. 2.42e+04. In the year 2008, what is the difference between the Emissions(kt) of Least developed countries and Emissions(kt) of Solomon Islands?
Your response must be concise. 1.16e+05. In the year 2008, what is the difference between the Emissions(kt) of South Asia and Emissions(kt) of Argentina?
Offer a terse response. 3.91e+05. In the year 2008, what is the difference between the Emissions(kt) of South Asia and Emissions(kt) of Solomon Islands?
Make the answer very short. 4.83e+05. In the year 2008, what is the difference between the Emissions(kt) in Argentina and Emissions(kt) in Solomon Islands?
Keep it short and to the point. 9.21e+04. In the year 2009, what is the difference between the Emissions(kt) in Least developed countries and Emissions(kt) in South Asia?
Your response must be concise. -4.11e+05. In the year 2009, what is the difference between the Emissions(kt) of Least developed countries and Emissions(kt) of Argentina?
Make the answer very short. 4.11e+04. In the year 2009, what is the difference between the Emissions(kt) in Least developed countries and Emissions(kt) in Solomon Islands?
Keep it short and to the point. 1.24e+05. In the year 2009, what is the difference between the Emissions(kt) of South Asia and Emissions(kt) of Argentina?
Your answer should be very brief. 4.52e+05. In the year 2009, what is the difference between the Emissions(kt) of South Asia and Emissions(kt) of Solomon Islands?
Offer a very short reply. 5.35e+05. In the year 2009, what is the difference between the Emissions(kt) of Argentina and Emissions(kt) of Solomon Islands?
Keep it short and to the point. 8.27e+04. What is the ratio of the Emissions(kt) of Least developed countries in 2002 to that in 2003?
Make the answer very short. 0.9. What is the ratio of the Emissions(kt) of South Asia in 2002 to that in 2003?
Provide a short and direct response. 1. What is the ratio of the Emissions(kt) of Argentina in 2002 to that in 2003?
Keep it short and to the point. 0.97. What is the ratio of the Emissions(kt) of Solomon Islands in 2002 to that in 2003?
Your answer should be compact. 0.96. What is the ratio of the Emissions(kt) of Least developed countries in 2002 to that in 2004?
Provide a succinct answer. 0.83. What is the ratio of the Emissions(kt) of South Asia in 2002 to that in 2004?
Provide a succinct answer. 0.97. What is the ratio of the Emissions(kt) of Argentina in 2002 to that in 2004?
Ensure brevity in your answer.  0.85. What is the ratio of the Emissions(kt) in Solomon Islands in 2002 to that in 2004?
Offer a very short reply. 0.96. What is the ratio of the Emissions(kt) of Least developed countries in 2002 to that in 2005?
Keep it short and to the point. 0.86. What is the ratio of the Emissions(kt) of South Asia in 2002 to that in 2005?
Keep it short and to the point. 0.97. What is the ratio of the Emissions(kt) in Argentina in 2002 to that in 2005?
Provide a short and direct response. 0.8. What is the ratio of the Emissions(kt) of Solomon Islands in 2002 to that in 2005?
Make the answer very short. 0.96. What is the ratio of the Emissions(kt) of Least developed countries in 2002 to that in 2006?
Give a very brief answer. 0.76. What is the ratio of the Emissions(kt) in South Asia in 2002 to that in 2006?
Your response must be concise. 0.9. What is the ratio of the Emissions(kt) in Argentina in 2002 to that in 2006?
Make the answer very short. 0.7. What is the ratio of the Emissions(kt) of Solomon Islands in 2002 to that in 2006?
Provide a short and direct response. 0.96. What is the ratio of the Emissions(kt) in Least developed countries in 2002 to that in 2007?
Give a very brief answer. 0.75. What is the ratio of the Emissions(kt) in South Asia in 2002 to that in 2007?
Provide a short and direct response. 0.89. What is the ratio of the Emissions(kt) in Argentina in 2002 to that in 2007?
Ensure brevity in your answer.  0.69. What is the ratio of the Emissions(kt) in Solomon Islands in 2002 to that in 2007?
Provide a short and direct response. 0.9. What is the ratio of the Emissions(kt) in Least developed countries in 2002 to that in 2008?
Provide a succinct answer. 0.69. What is the ratio of the Emissions(kt) of South Asia in 2002 to that in 2008?
Your answer should be very brief. 0.75. What is the ratio of the Emissions(kt) in Argentina in 2002 to that in 2008?
Offer a terse response. 0.62. What is the ratio of the Emissions(kt) in Solomon Islands in 2002 to that in 2008?
Provide a succinct answer. 0.9. What is the ratio of the Emissions(kt) of Least developed countries in 2002 to that in 2009?
Provide a succinct answer. 0.65. What is the ratio of the Emissions(kt) of South Asia in 2002 to that in 2009?
Make the answer very short. 0.68. What is the ratio of the Emissions(kt) in Argentina in 2002 to that in 2009?
Your answer should be compact. 0.69. What is the ratio of the Emissions(kt) in Solomon Islands in 2002 to that in 2009?
Make the answer very short. 0.89. What is the ratio of the Emissions(kt) of Least developed countries in 2003 to that in 2004?
Give a very brief answer. 0.92. What is the ratio of the Emissions(kt) of South Asia in 2003 to that in 2004?
Make the answer very short. 0.97. What is the ratio of the Emissions(kt) in Argentina in 2003 to that in 2004?
Make the answer very short. 0.88. What is the ratio of the Emissions(kt) of Solomon Islands in 2003 to that in 2004?
Keep it short and to the point. 1. What is the ratio of the Emissions(kt) of Least developed countries in 2003 to that in 2005?
Offer a terse response. 0.96. What is the ratio of the Emissions(kt) in South Asia in 2003 to that in 2005?
Keep it short and to the point. 0.97. What is the ratio of the Emissions(kt) in Argentina in 2003 to that in 2005?
Provide a succinct answer. 0.83. What is the ratio of the Emissions(kt) of Solomon Islands in 2003 to that in 2005?
Keep it short and to the point. 1. What is the ratio of the Emissions(kt) of Least developed countries in 2003 to that in 2006?
Your answer should be compact. 0.84. What is the ratio of the Emissions(kt) in South Asia in 2003 to that in 2006?
Offer a terse response. 0.9. What is the ratio of the Emissions(kt) in Argentina in 2003 to that in 2006?
Offer a very short reply. 0.72. What is the ratio of the Emissions(kt) of Least developed countries in 2003 to that in 2007?
Keep it short and to the point. 0.84. What is the ratio of the Emissions(kt) in South Asia in 2003 to that in 2007?
Your answer should be very brief. 0.89. What is the ratio of the Emissions(kt) in Argentina in 2003 to that in 2007?
Provide a succinct answer. 0.71. What is the ratio of the Emissions(kt) in Solomon Islands in 2003 to that in 2007?
Offer a terse response. 0.94. What is the ratio of the Emissions(kt) of Least developed countries in 2003 to that in 2008?
Give a very brief answer. 0.77. What is the ratio of the Emissions(kt) in South Asia in 2003 to that in 2008?
Keep it short and to the point. 0.75. What is the ratio of the Emissions(kt) in Argentina in 2003 to that in 2008?
Your answer should be compact. 0.64. What is the ratio of the Emissions(kt) of Solomon Islands in 2003 to that in 2008?
Keep it short and to the point. 0.94. What is the ratio of the Emissions(kt) in Least developed countries in 2003 to that in 2009?
Ensure brevity in your answer.  0.72. What is the ratio of the Emissions(kt) in South Asia in 2003 to that in 2009?
Offer a very short reply. 0.68. What is the ratio of the Emissions(kt) in Argentina in 2003 to that in 2009?
Provide a succinct answer. 0.72. What is the ratio of the Emissions(kt) of Solomon Islands in 2003 to that in 2009?
Ensure brevity in your answer.  0.92. What is the ratio of the Emissions(kt) of Least developed countries in 2004 to that in 2005?
Offer a very short reply. 1.04. What is the ratio of the Emissions(kt) in Argentina in 2004 to that in 2005?
Keep it short and to the point. 0.94. What is the ratio of the Emissions(kt) of Solomon Islands in 2004 to that in 2005?
Your response must be concise. 1. What is the ratio of the Emissions(kt) of Least developed countries in 2004 to that in 2006?
Keep it short and to the point. 0.91. What is the ratio of the Emissions(kt) in South Asia in 2004 to that in 2006?
Give a very brief answer. 0.92. What is the ratio of the Emissions(kt) of Argentina in 2004 to that in 2006?
Offer a very short reply. 0.83. What is the ratio of the Emissions(kt) in Solomon Islands in 2004 to that in 2006?
Make the answer very short. 1. What is the ratio of the Emissions(kt) in Least developed countries in 2004 to that in 2007?
Keep it short and to the point. 0.91. What is the ratio of the Emissions(kt) of South Asia in 2004 to that in 2007?
Your answer should be very brief. 0.91. What is the ratio of the Emissions(kt) in Argentina in 2004 to that in 2007?
Your response must be concise. 0.81. What is the ratio of the Emissions(kt) in Solomon Islands in 2004 to that in 2007?
Keep it short and to the point. 0.94. What is the ratio of the Emissions(kt) in Least developed countries in 2004 to that in 2008?
Make the answer very short. 0.83. What is the ratio of the Emissions(kt) in South Asia in 2004 to that in 2008?
Keep it short and to the point. 0.77. What is the ratio of the Emissions(kt) of Argentina in 2004 to that in 2008?
Your answer should be very brief. 0.74. What is the ratio of the Emissions(kt) of Solomon Islands in 2004 to that in 2008?
Your answer should be compact. 0.94. What is the ratio of the Emissions(kt) in Least developed countries in 2004 to that in 2009?
Provide a succinct answer. 0.78. What is the ratio of the Emissions(kt) of South Asia in 2004 to that in 2009?
Offer a very short reply. 0.7. What is the ratio of the Emissions(kt) of Argentina in 2004 to that in 2009?
Provide a succinct answer. 0.82. What is the ratio of the Emissions(kt) of Solomon Islands in 2004 to that in 2009?
Your answer should be compact. 0.92. What is the ratio of the Emissions(kt) in Least developed countries in 2005 to that in 2006?
Your answer should be compact. 0.88. What is the ratio of the Emissions(kt) in South Asia in 2005 to that in 2006?
Give a very brief answer. 0.93. What is the ratio of the Emissions(kt) in Argentina in 2005 to that in 2006?
Provide a short and direct response. 0.88. What is the ratio of the Emissions(kt) of Solomon Islands in 2005 to that in 2006?
Give a very brief answer. 1. What is the ratio of the Emissions(kt) of Least developed countries in 2005 to that in 2007?
Offer a very short reply. 0.88. What is the ratio of the Emissions(kt) in South Asia in 2005 to that in 2007?
Provide a short and direct response. 0.92. What is the ratio of the Emissions(kt) in Argentina in 2005 to that in 2007?
Offer a very short reply. 0.86. What is the ratio of the Emissions(kt) in Solomon Islands in 2005 to that in 2007?
Make the answer very short. 0.94. What is the ratio of the Emissions(kt) of Least developed countries in 2005 to that in 2008?
Ensure brevity in your answer.  0.81. What is the ratio of the Emissions(kt) of South Asia in 2005 to that in 2008?
Ensure brevity in your answer.  0.77. What is the ratio of the Emissions(kt) of Argentina in 2005 to that in 2008?
Your response must be concise. 0.78. What is the ratio of the Emissions(kt) of Solomon Islands in 2005 to that in 2008?
Your answer should be very brief. 0.94. What is the ratio of the Emissions(kt) in Least developed countries in 2005 to that in 2009?
Provide a short and direct response. 0.76. What is the ratio of the Emissions(kt) of South Asia in 2005 to that in 2009?
Provide a succinct answer. 0.7. What is the ratio of the Emissions(kt) in Argentina in 2005 to that in 2009?
Your answer should be compact. 0.87. What is the ratio of the Emissions(kt) in Solomon Islands in 2005 to that in 2009?
Keep it short and to the point. 0.92. What is the ratio of the Emissions(kt) of South Asia in 2006 to that in 2007?
Your answer should be very brief. 0.99. What is the ratio of the Emissions(kt) in Argentina in 2006 to that in 2007?
Make the answer very short. 0.98. What is the ratio of the Emissions(kt) in Solomon Islands in 2006 to that in 2007?
Keep it short and to the point. 0.94. What is the ratio of the Emissions(kt) of Least developed countries in 2006 to that in 2008?
Make the answer very short. 0.91. What is the ratio of the Emissions(kt) in South Asia in 2006 to that in 2008?
Keep it short and to the point. 0.83. What is the ratio of the Emissions(kt) of Argentina in 2006 to that in 2008?
Provide a short and direct response. 0.89. What is the ratio of the Emissions(kt) in Solomon Islands in 2006 to that in 2008?
Make the answer very short. 0.94. What is the ratio of the Emissions(kt) of Least developed countries in 2006 to that in 2009?
Your response must be concise. 0.86. What is the ratio of the Emissions(kt) in South Asia in 2006 to that in 2009?
Ensure brevity in your answer.  0.75. What is the ratio of the Emissions(kt) in Solomon Islands in 2006 to that in 2009?
Offer a terse response. 0.92. What is the ratio of the Emissions(kt) of Least developed countries in 2007 to that in 2008?
Offer a terse response. 0.92. What is the ratio of the Emissions(kt) of South Asia in 2007 to that in 2008?
Keep it short and to the point. 0.84. What is the ratio of the Emissions(kt) of Argentina in 2007 to that in 2008?
Make the answer very short. 0.9. What is the ratio of the Emissions(kt) of Least developed countries in 2007 to that in 2009?
Keep it short and to the point. 0.86. What is the ratio of the Emissions(kt) in South Asia in 2007 to that in 2009?
Give a very brief answer. 0.76. What is the ratio of the Emissions(kt) of Argentina in 2007 to that in 2009?
Make the answer very short. 1.01. What is the ratio of the Emissions(kt) in Solomon Islands in 2007 to that in 2009?
Your answer should be very brief. 0.98. What is the ratio of the Emissions(kt) of Least developed countries in 2008 to that in 2009?
Your answer should be compact. 0.94. What is the ratio of the Emissions(kt) of South Asia in 2008 to that in 2009?
Provide a short and direct response. 0.9. What is the ratio of the Emissions(kt) in Argentina in 2008 to that in 2009?
Your response must be concise. 1.11. What is the ratio of the Emissions(kt) in Solomon Islands in 2008 to that in 2009?
Give a very brief answer. 0.98. What is the difference between the highest and the second highest Emissions(kt) in Least developed countries?
Ensure brevity in your answer.  7571.93. What is the difference between the highest and the second highest Emissions(kt) of South Asia?
Your answer should be compact. 5.21e+04. What is the difference between the highest and the second highest Emissions(kt) of Argentina?
Offer a very short reply. 8815.47. What is the difference between the highest and the second highest Emissions(kt) in Solomon Islands?
Give a very brief answer. 3.67. What is the difference between the highest and the lowest Emissions(kt) in Least developed countries?
Your answer should be compact. 4.32e+04. What is the difference between the highest and the lowest Emissions(kt) of South Asia?
Offer a very short reply. 1.74e+05. What is the difference between the highest and the lowest Emissions(kt) in Argentina?
Your answer should be very brief. 3.48e+04. What is the difference between the highest and the lowest Emissions(kt) of Solomon Islands?
Your answer should be compact. 22. 